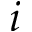<formula> <loc_0><loc_0><loc_500><loc_500>i</formula> 